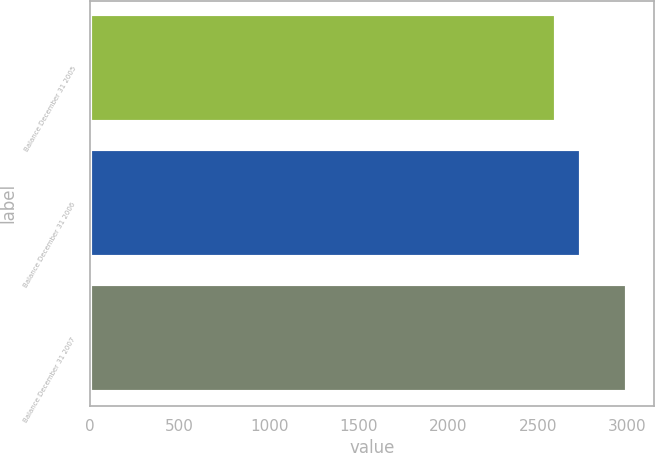Convert chart to OTSL. <chart><loc_0><loc_0><loc_500><loc_500><bar_chart><fcel>Balance December 31 2005<fcel>Balance December 31 2006<fcel>Balance December 31 2007<nl><fcel>2601.1<fcel>2743.2<fcel>2999.1<nl></chart> 